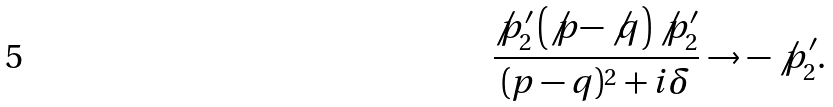Convert formula to latex. <formula><loc_0><loc_0><loc_500><loc_500>\frac { \not p _ { 2 } ^ { \prime } \left ( \not p - \not q \right ) \not p _ { 2 } ^ { \prime } } { ( p - q ) ^ { 2 } + i \delta } \rightarrow - \not p _ { 2 } ^ { \prime } .</formula> 